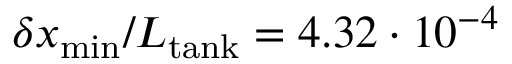<formula> <loc_0><loc_0><loc_500><loc_500>\delta x _ { \min } / L _ { t a n k } = 4 . 3 2 \cdot 1 0 ^ { - 4 }</formula> 